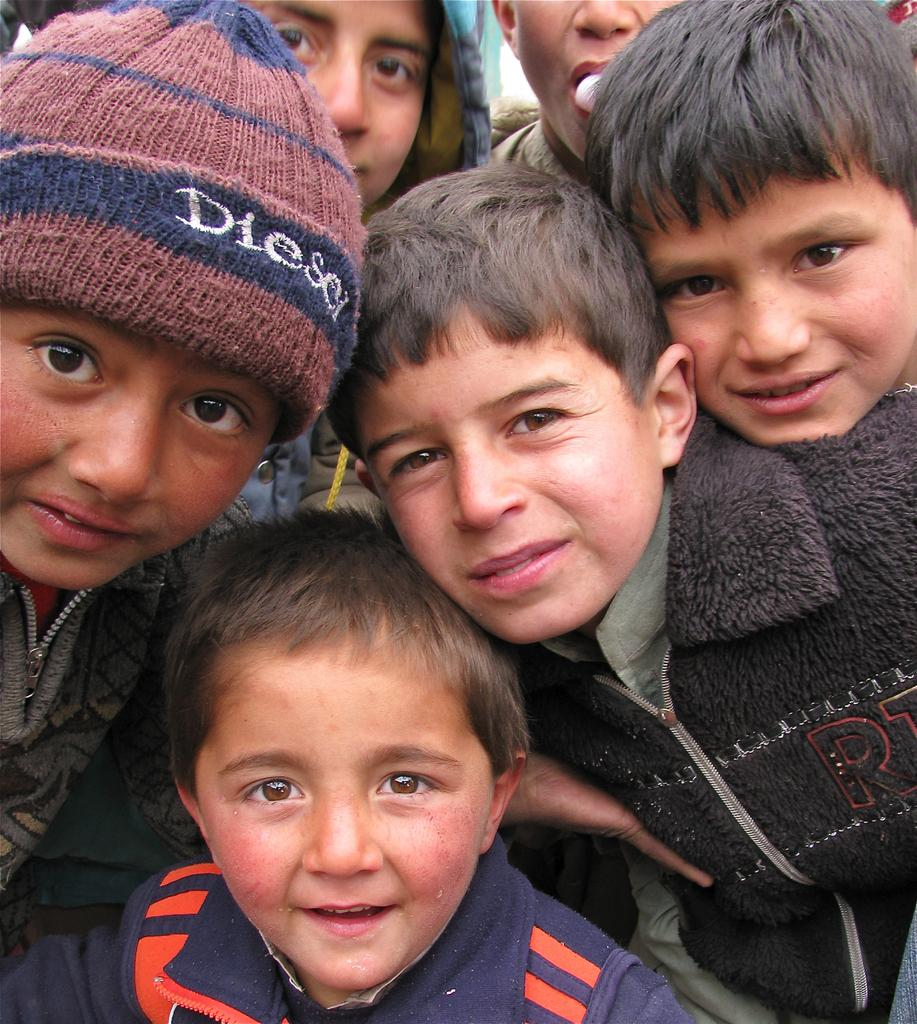What is the main subject of the image? The main subject of the image is a group of children. What type of word can be seen written on the seashore in the image? There is no word or seashore present in the image; it features a group of children. 